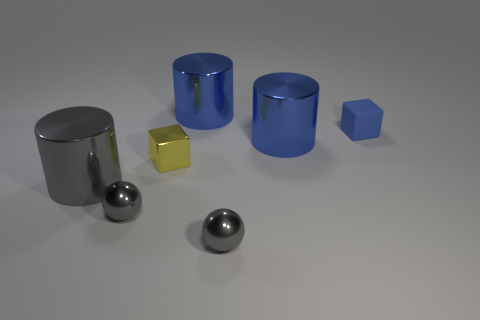The tiny sphere that is on the left side of the shiny cylinder that is behind the matte thing is what color?
Offer a terse response. Gray. Is there a big green thing?
Your answer should be very brief. No. Do the tiny yellow shiny thing and the tiny blue rubber thing have the same shape?
Offer a very short reply. Yes. How many metallic cylinders are behind the blue shiny object that is in front of the matte cube?
Give a very brief answer. 1. How many objects are right of the big gray object and left of the tiny blue object?
Your answer should be very brief. 5. What number of objects are either big gray cylinders or metallic things that are to the left of the yellow object?
Your answer should be compact. 2. There is a gray cylinder that is the same material as the yellow cube; what is its size?
Make the answer very short. Large. There is a small object behind the block in front of the tiny blue matte block; what shape is it?
Give a very brief answer. Cube. How many blue things are either large objects or tiny shiny blocks?
Your answer should be compact. 2. There is a tiny shiny thing on the right side of the big shiny thing behind the blue matte thing; is there a rubber cube that is on the right side of it?
Provide a succinct answer. Yes. 